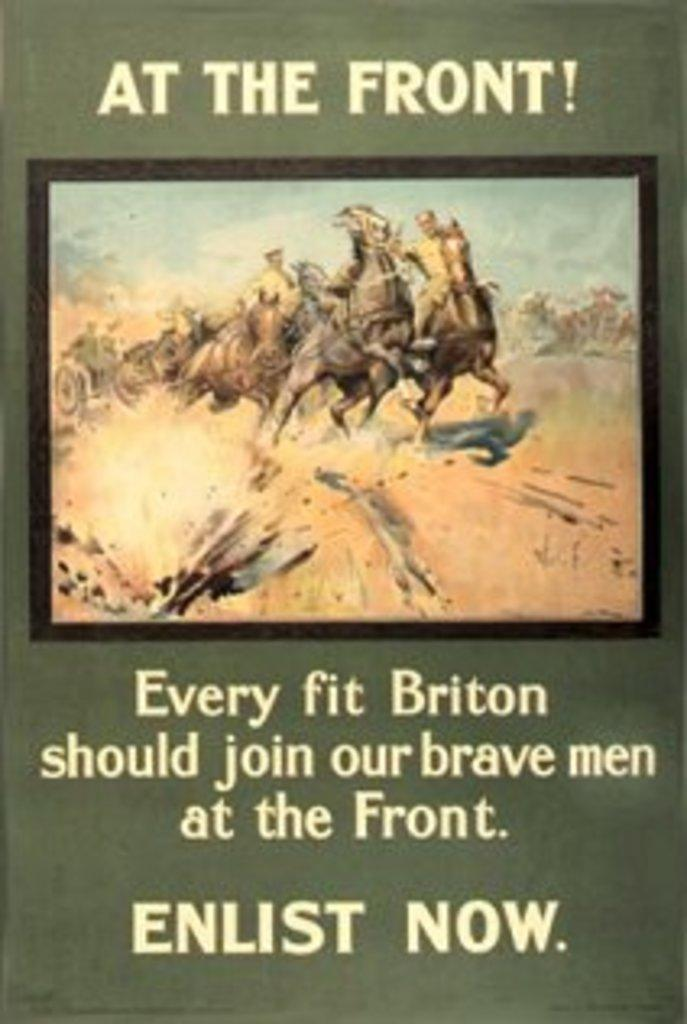<image>
Relay a brief, clear account of the picture shown. A poster stating At The Front!  Enlist Now. 